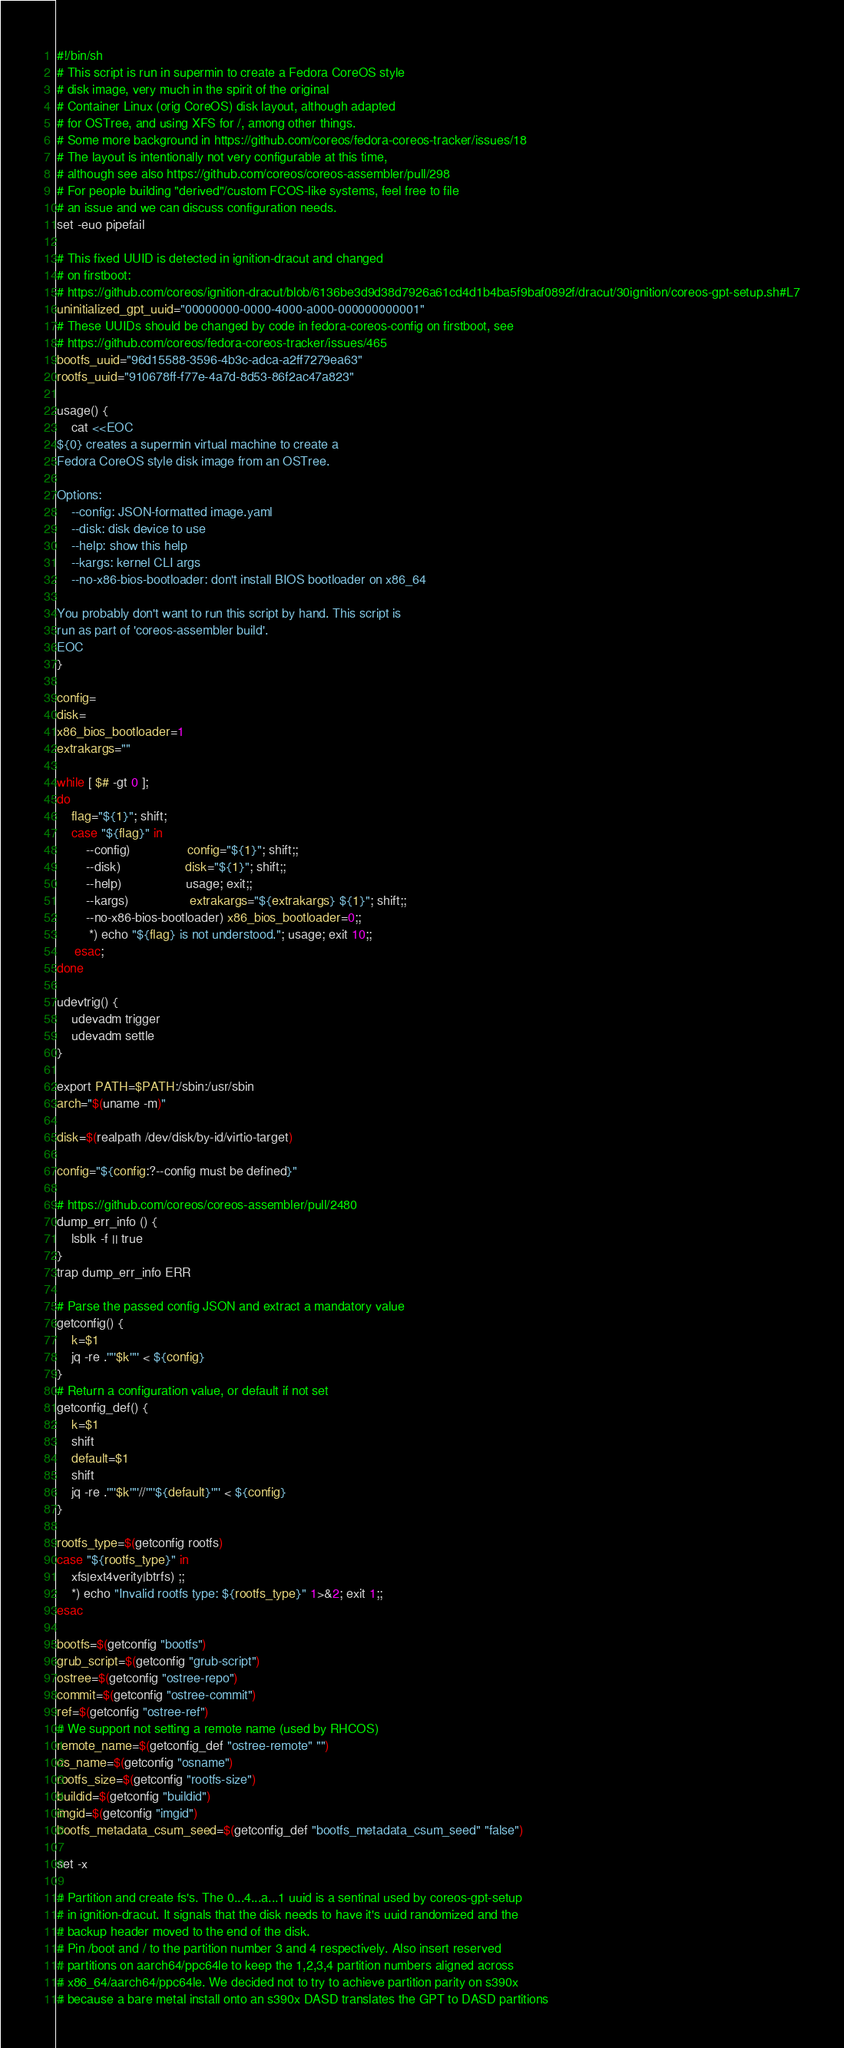<code> <loc_0><loc_0><loc_500><loc_500><_Bash_>#!/bin/sh
# This script is run in supermin to create a Fedora CoreOS style
# disk image, very much in the spirit of the original
# Container Linux (orig CoreOS) disk layout, although adapted
# for OSTree, and using XFS for /, among other things.
# Some more background in https://github.com/coreos/fedora-coreos-tracker/issues/18
# The layout is intentionally not very configurable at this time,
# although see also https://github.com/coreos/coreos-assembler/pull/298
# For people building "derived"/custom FCOS-like systems, feel free to file
# an issue and we can discuss configuration needs.
set -euo pipefail

# This fixed UUID is detected in ignition-dracut and changed
# on firstboot:
# https://github.com/coreos/ignition-dracut/blob/6136be3d9d38d7926a61cd4d1b4ba5f9baf0892f/dracut/30ignition/coreos-gpt-setup.sh#L7
uninitialized_gpt_uuid="00000000-0000-4000-a000-000000000001"
# These UUIDs should be changed by code in fedora-coreos-config on firstboot, see
# https://github.com/coreos/fedora-coreos-tracker/issues/465
bootfs_uuid="96d15588-3596-4b3c-adca-a2ff7279ea63"
rootfs_uuid="910678ff-f77e-4a7d-8d53-86f2ac47a823"

usage() {
    cat <<EOC
${0} creates a supermin virtual machine to create a
Fedora CoreOS style disk image from an OSTree.

Options:
    --config: JSON-formatted image.yaml
    --disk: disk device to use
    --help: show this help
    --kargs: kernel CLI args
    --no-x86-bios-bootloader: don't install BIOS bootloader on x86_64

You probably don't want to run this script by hand. This script is
run as part of 'coreos-assembler build'.
EOC
}

config=
disk=
x86_bios_bootloader=1
extrakargs=""

while [ $# -gt 0 ];
do
    flag="${1}"; shift;
    case "${flag}" in
        --config)                config="${1}"; shift;;
        --disk)                  disk="${1}"; shift;;
        --help)                  usage; exit;;
        --kargs)                 extrakargs="${extrakargs} ${1}"; shift;;
        --no-x86-bios-bootloader) x86_bios_bootloader=0;;
         *) echo "${flag} is not understood."; usage; exit 10;;
     esac;
done

udevtrig() {
    udevadm trigger
    udevadm settle
}

export PATH=$PATH:/sbin:/usr/sbin
arch="$(uname -m)"

disk=$(realpath /dev/disk/by-id/virtio-target)

config="${config:?--config must be defined}"

# https://github.com/coreos/coreos-assembler/pull/2480
dump_err_info () {
    lsblk -f || true
}
trap dump_err_info ERR

# Parse the passed config JSON and extract a mandatory value
getconfig() {
    k=$1
    jq -re .'"'$k'"' < ${config}
}
# Return a configuration value, or default if not set
getconfig_def() {
    k=$1
    shift
    default=$1
    shift
    jq -re .'"'$k'"'//'"'${default}'"' < ${config}
}

rootfs_type=$(getconfig rootfs)
case "${rootfs_type}" in
    xfs|ext4verity|btrfs) ;;
    *) echo "Invalid rootfs type: ${rootfs_type}" 1>&2; exit 1;;
esac

bootfs=$(getconfig "bootfs")
grub_script=$(getconfig "grub-script")
ostree=$(getconfig "ostree-repo")
commit=$(getconfig "ostree-commit")
ref=$(getconfig "ostree-ref")
# We support not setting a remote name (used by RHCOS)
remote_name=$(getconfig_def "ostree-remote" "")
os_name=$(getconfig "osname")
rootfs_size=$(getconfig "rootfs-size")
buildid=$(getconfig "buildid")
imgid=$(getconfig "imgid")
bootfs_metadata_csum_seed=$(getconfig_def "bootfs_metadata_csum_seed" "false")

set -x

# Partition and create fs's. The 0...4...a...1 uuid is a sentinal used by coreos-gpt-setup
# in ignition-dracut. It signals that the disk needs to have it's uuid randomized and the
# backup header moved to the end of the disk.
# Pin /boot and / to the partition number 3 and 4 respectively. Also insert reserved
# partitions on aarch64/ppc64le to keep the 1,2,3,4 partition numbers aligned across
# x86_64/aarch64/ppc64le. We decided not to try to achieve partition parity on s390x
# because a bare metal install onto an s390x DASD translates the GPT to DASD partitions</code> 